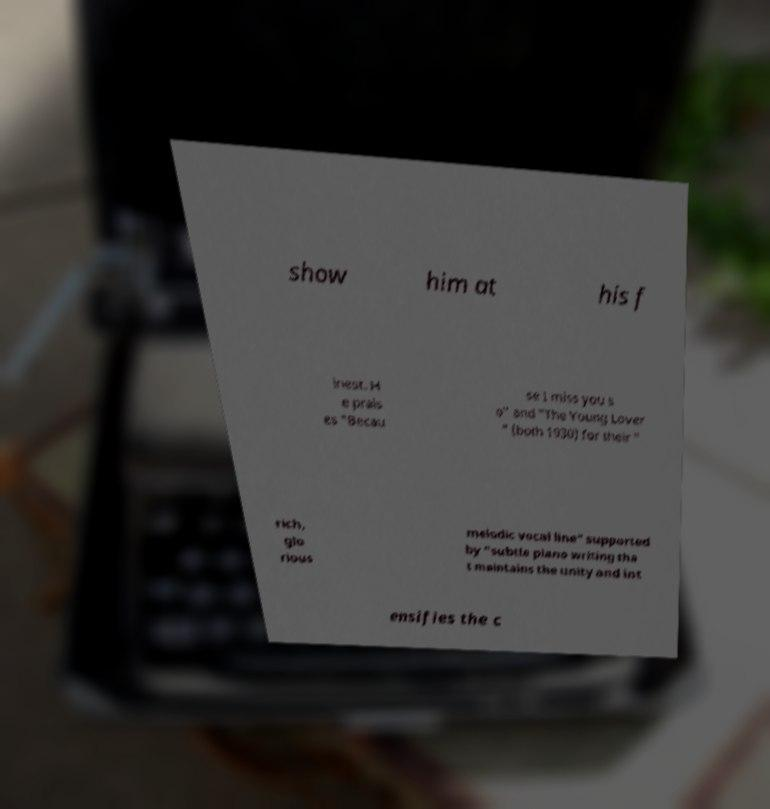Can you read and provide the text displayed in the image?This photo seems to have some interesting text. Can you extract and type it out for me? show him at his f inest. H e prais es "Becau se I miss you s o" and "The Young Lover " (both 1930) for their " rich, glo rious melodic vocal line" supported by "subtle piano writing tha t maintains the unity and int ensifies the c 